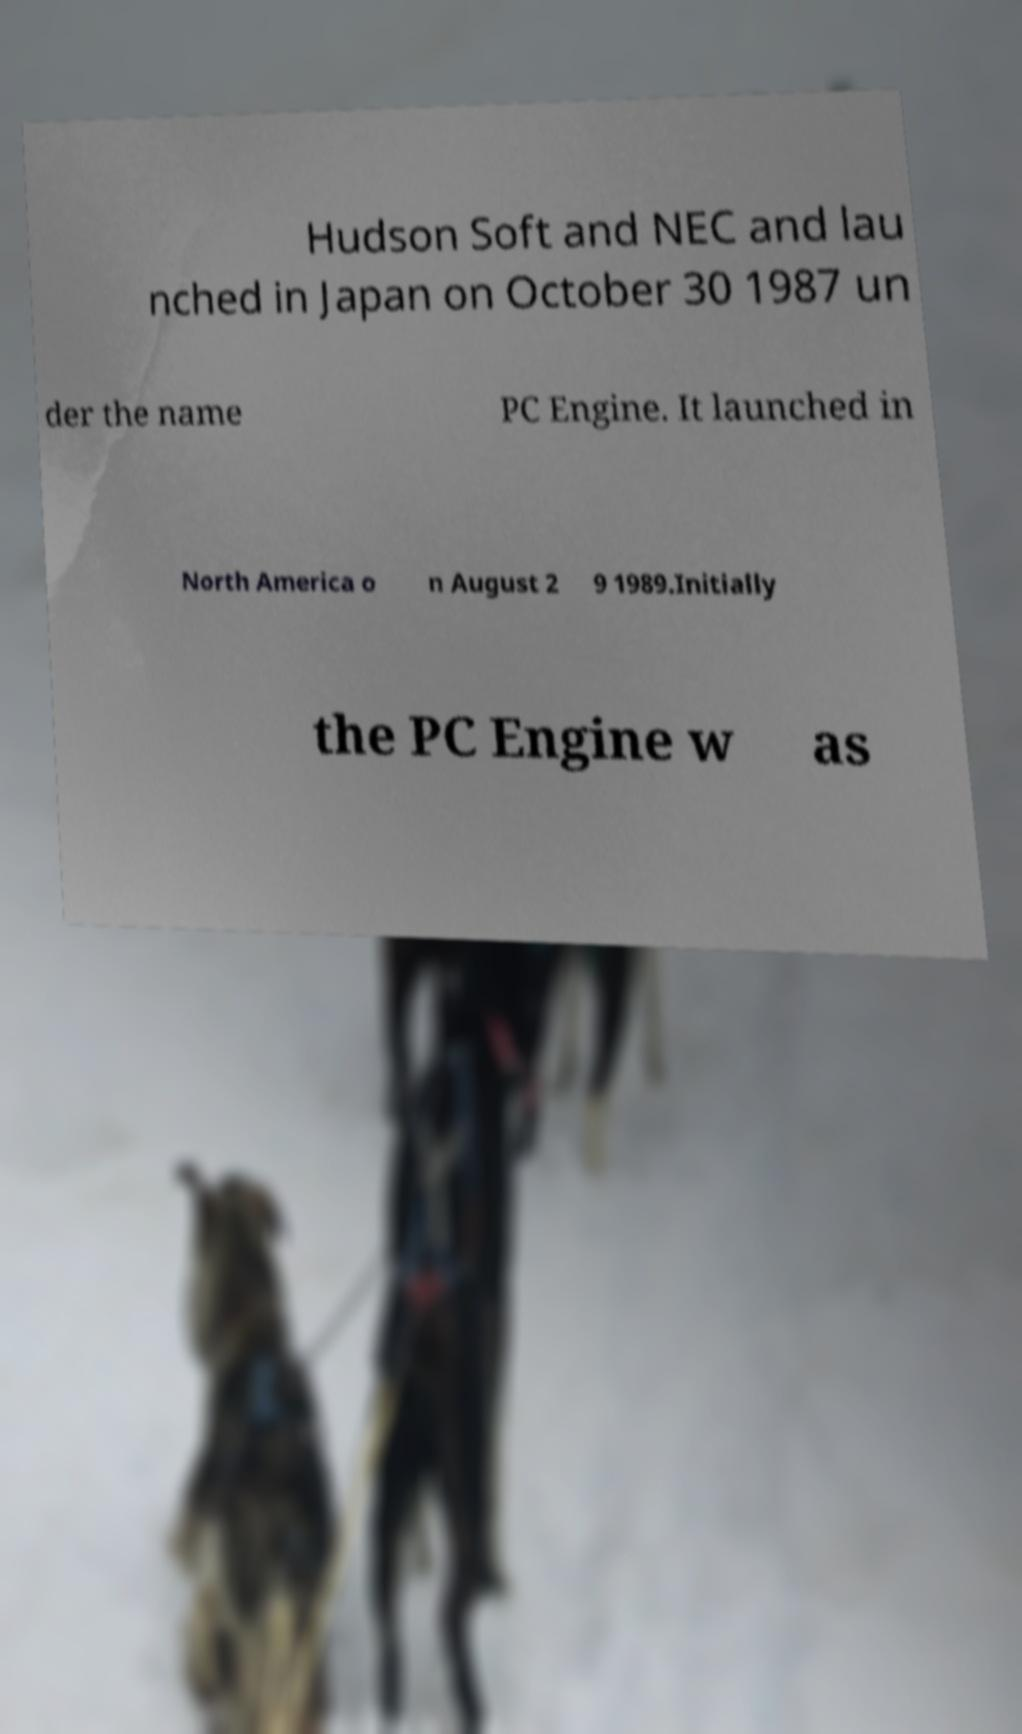For documentation purposes, I need the text within this image transcribed. Could you provide that? Hudson Soft and NEC and lau nched in Japan on October 30 1987 un der the name PC Engine. It launched in North America o n August 2 9 1989.Initially the PC Engine w as 